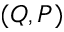Convert formula to latex. <formula><loc_0><loc_0><loc_500><loc_500>( Q , P )</formula> 